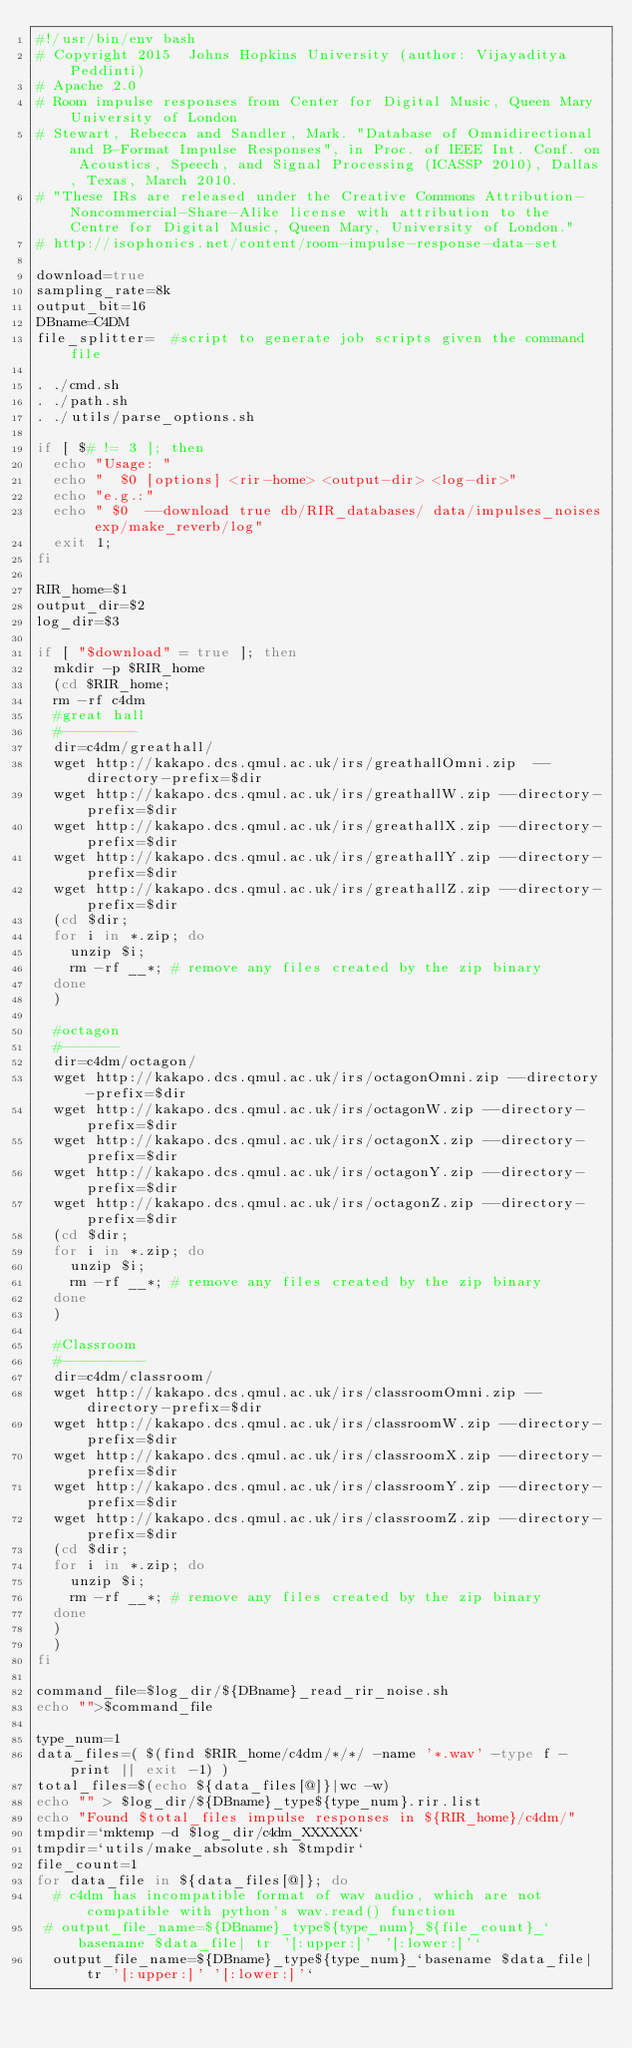<code> <loc_0><loc_0><loc_500><loc_500><_Bash_>#!/usr/bin/env bash
# Copyright 2015  Johns Hopkins University (author: Vijayaditya Peddinti)
# Apache 2.0
# Room impulse responses from Center for Digital Music, Queen Mary University of London
# Stewart, Rebecca and Sandler, Mark. "Database of Omnidirectional and B-Format Impulse Responses", in Proc. of IEEE Int. Conf. on Acoustics, Speech, and Signal Processing (ICASSP 2010), Dallas, Texas, March 2010.
# "These IRs are released under the Creative Commons Attribution-Noncommercial-Share-Alike license with attribution to the Centre for Digital Music, Queen Mary, University of London."
# http://isophonics.net/content/room-impulse-response-data-set

download=true 
sampling_rate=8k
output_bit=16
DBname=C4DM
file_splitter=  #script to generate job scripts given the command file

. ./cmd.sh
. ./path.sh
. ./utils/parse_options.sh

if [ $# != 3 ]; then
  echo "Usage: "
  echo "  $0 [options] <rir-home> <output-dir> <log-dir>"
  echo "e.g.:"
  echo " $0  --download true db/RIR_databases/ data/impulses_noises exp/make_reverb/log"
  exit 1;
fi

RIR_home=$1
output_dir=$2
log_dir=$3

if [ "$download" = true ]; then
  mkdir -p $RIR_home
  (cd $RIR_home;
  rm -rf c4dm
  #great hall
  #---------
  dir=c4dm/greathall/
  wget http://kakapo.dcs.qmul.ac.uk/irs/greathallOmni.zip  --directory-prefix=$dir
  wget http://kakapo.dcs.qmul.ac.uk/irs/greathallW.zip --directory-prefix=$dir
  wget http://kakapo.dcs.qmul.ac.uk/irs/greathallX.zip --directory-prefix=$dir
  wget http://kakapo.dcs.qmul.ac.uk/irs/greathallY.zip --directory-prefix=$dir
  wget http://kakapo.dcs.qmul.ac.uk/irs/greathallZ.zip --directory-prefix=$dir
  (cd $dir;
  for i in *.zip; do
    unzip $i;
    rm -rf __*; # remove any files created by the zip binary
  done
  )

  #octagon
  #-------
  dir=c4dm/octagon/
  wget http://kakapo.dcs.qmul.ac.uk/irs/octagonOmni.zip --directory-prefix=$dir
  wget http://kakapo.dcs.qmul.ac.uk/irs/octagonW.zip --directory-prefix=$dir
  wget http://kakapo.dcs.qmul.ac.uk/irs/octagonX.zip --directory-prefix=$dir
  wget http://kakapo.dcs.qmul.ac.uk/irs/octagonY.zip --directory-prefix=$dir
  wget http://kakapo.dcs.qmul.ac.uk/irs/octagonZ.zip --directory-prefix=$dir
  (cd $dir;
  for i in *.zip; do
    unzip $i;
    rm -rf __*; # remove any files created by the zip binary
  done
  )

  #Classroom
  #----------
  dir=c4dm/classroom/
  wget http://kakapo.dcs.qmul.ac.uk/irs/classroomOmni.zip --directory-prefix=$dir
  wget http://kakapo.dcs.qmul.ac.uk/irs/classroomW.zip --directory-prefix=$dir
  wget http://kakapo.dcs.qmul.ac.uk/irs/classroomX.zip --directory-prefix=$dir
  wget http://kakapo.dcs.qmul.ac.uk/irs/classroomY.zip --directory-prefix=$dir
  wget http://kakapo.dcs.qmul.ac.uk/irs/classroomZ.zip --directory-prefix=$dir
  (cd $dir;
  for i in *.zip; do
    unzip $i;
    rm -rf __*; # remove any files created by the zip binary
  done
  )
  )
fi

command_file=$log_dir/${DBname}_read_rir_noise.sh
echo "">$command_file

type_num=1
data_files=( $(find $RIR_home/c4dm/*/*/ -name '*.wav' -type f -print || exit -1) )
total_files=$(echo ${data_files[@]}|wc -w)
echo "" > $log_dir/${DBname}_type${type_num}.rir.list
echo "Found $total_files impulse responses in ${RIR_home}/c4dm/"
tmpdir=`mktemp -d $log_dir/c4dm_XXXXXX`
tmpdir=`utils/make_absolute.sh $tmpdir`
file_count=1
for data_file in ${data_files[@]}; do
  # c4dm has incompatible format of wav audio, which are not compatible with python's wav.read() function
 # output_file_name=${DBname}_type${type_num}_${file_count}_`basename $data_file| tr '[:upper:]' '[:lower:]'`
  output_file_name=${DBname}_type${type_num}_`basename $data_file| tr '[:upper:]' '[:lower:]'`</code> 